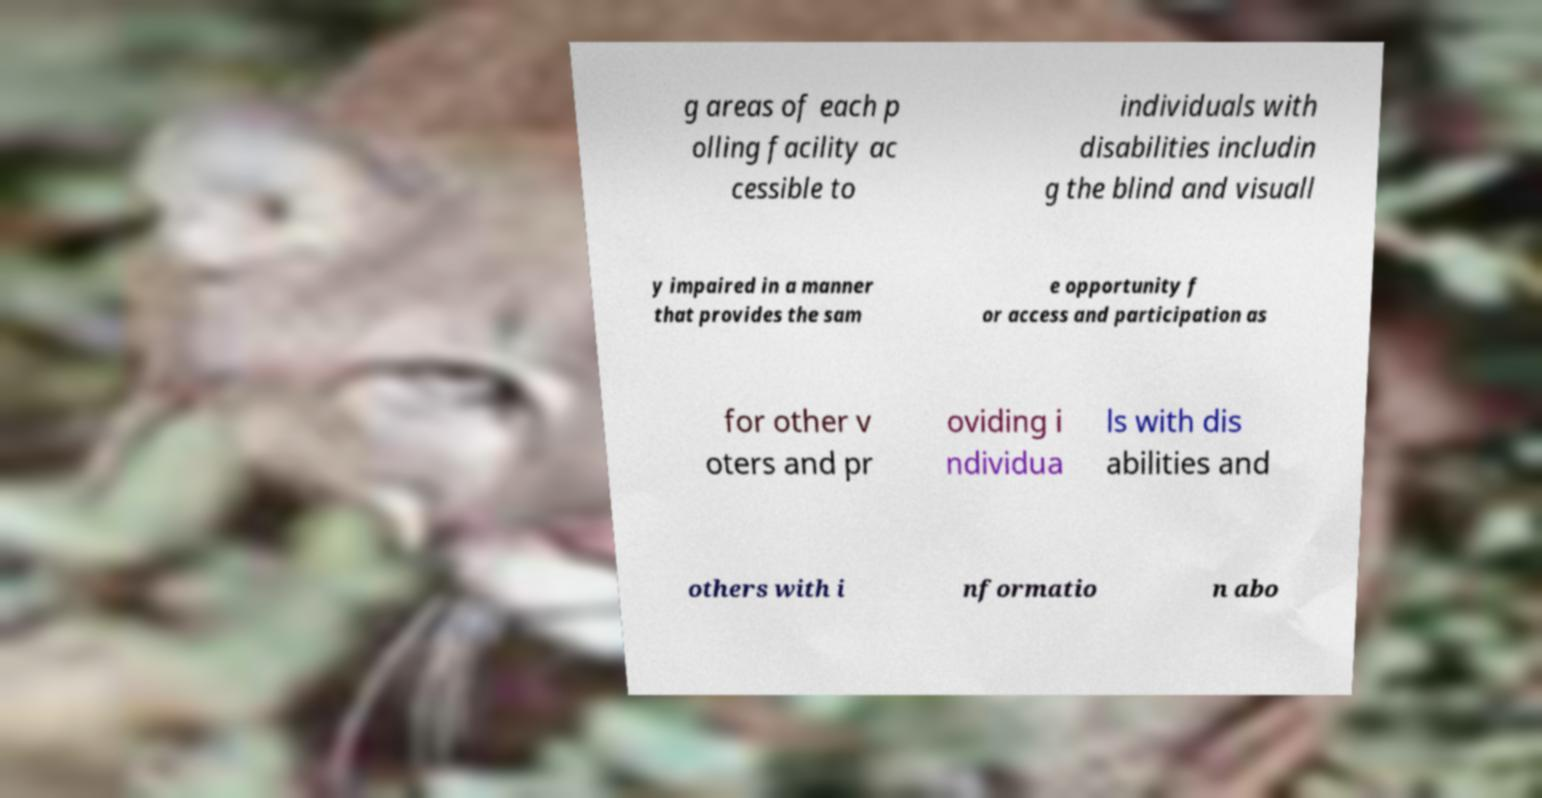Can you read and provide the text displayed in the image?This photo seems to have some interesting text. Can you extract and type it out for me? g areas of each p olling facility ac cessible to individuals with disabilities includin g the blind and visuall y impaired in a manner that provides the sam e opportunity f or access and participation as for other v oters and pr oviding i ndividua ls with dis abilities and others with i nformatio n abo 